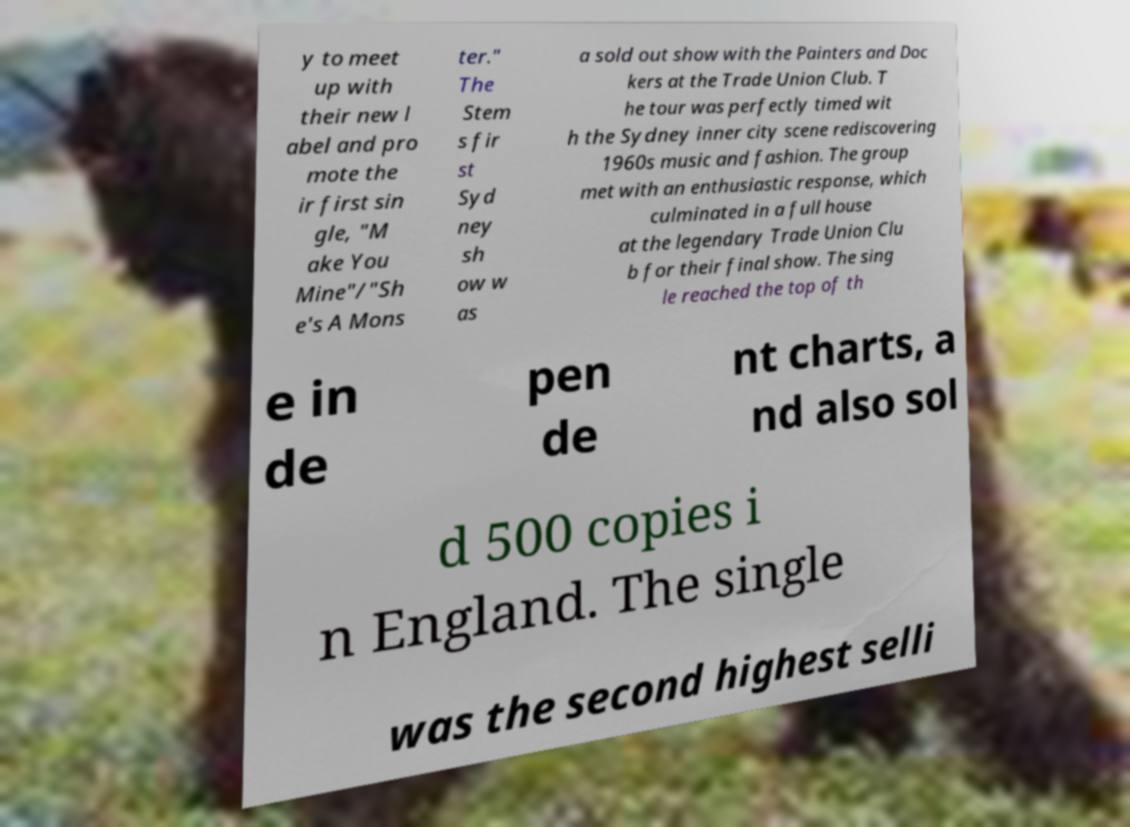There's text embedded in this image that I need extracted. Can you transcribe it verbatim? y to meet up with their new l abel and pro mote the ir first sin gle, "M ake You Mine"/"Sh e's A Mons ter." The Stem s fir st Syd ney sh ow w as a sold out show with the Painters and Doc kers at the Trade Union Club. T he tour was perfectly timed wit h the Sydney inner city scene rediscovering 1960s music and fashion. The group met with an enthusiastic response, which culminated in a full house at the legendary Trade Union Clu b for their final show. The sing le reached the top of th e in de pen de nt charts, a nd also sol d 500 copies i n England. The single was the second highest selli 